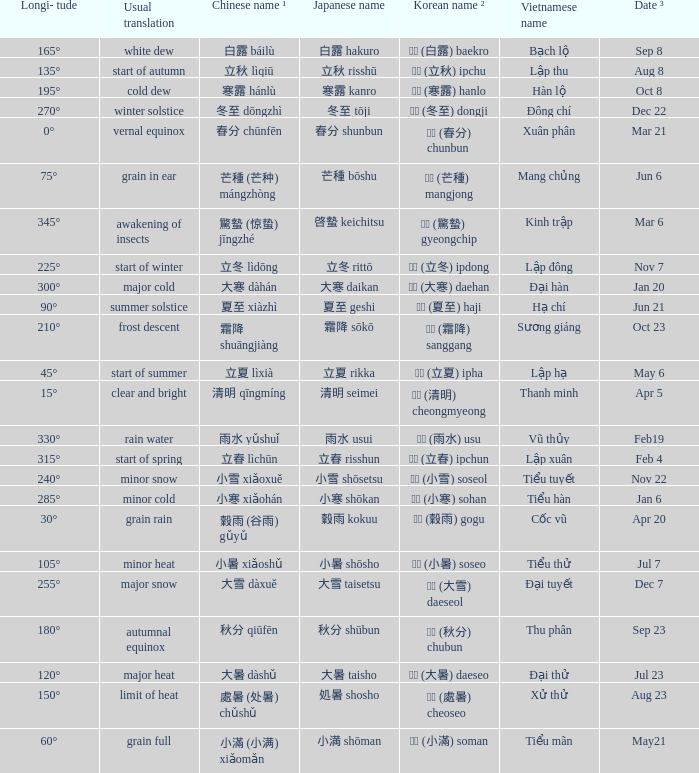Could you parse the entire table? {'header': ['Longi- tude', 'Usual translation', 'Chinese name ¹', 'Japanese name', 'Korean name ²', 'Vietnamese name', 'Date ³'], 'rows': [['165°', 'white dew', '白露 báilù', '白露 hakuro', '백로 (白露) baekro', 'Bạch lộ', 'Sep 8'], ['135°', 'start of autumn', '立秋 lìqiū', '立秋 risshū', '입추 (立秋) ipchu', 'Lập thu', 'Aug 8'], ['195°', 'cold dew', '寒露 hánlù', '寒露 kanro', '한로 (寒露) hanlo', 'Hàn lộ', 'Oct 8'], ['270°', 'winter solstice', '冬至 dōngzhì', '冬至 tōji', '동지 (冬至) dongji', 'Đông chí', 'Dec 22'], ['0°', 'vernal equinox', '春分 chūnfēn', '春分 shunbun', '춘분 (春分) chunbun', 'Xuân phân', 'Mar 21'], ['75°', 'grain in ear', '芒種 (芒种) mángzhòng', '芒種 bōshu', '망종 (芒種) mangjong', 'Mang chủng', 'Jun 6'], ['345°', 'awakening of insects', '驚蟄 (惊蛰) jīngzhé', '啓蟄 keichitsu', '경칩 (驚蟄) gyeongchip', 'Kinh trập', 'Mar 6'], ['225°', 'start of winter', '立冬 lìdōng', '立冬 rittō', '입동 (立冬) ipdong', 'Lập đông', 'Nov 7'], ['300°', 'major cold', '大寒 dàhán', '大寒 daikan', '대한 (大寒) daehan', 'Đại hàn', 'Jan 20'], ['90°', 'summer solstice', '夏至 xiàzhì', '夏至 geshi', '하지 (夏至) haji', 'Hạ chí', 'Jun 21'], ['210°', 'frost descent', '霜降 shuāngjiàng', '霜降 sōkō', '상강 (霜降) sanggang', 'Sương giáng', 'Oct 23'], ['45°', 'start of summer', '立夏 lìxià', '立夏 rikka', '입하 (立夏) ipha', 'Lập hạ', 'May 6'], ['15°', 'clear and bright', '清明 qīngmíng', '清明 seimei', '청명 (清明) cheongmyeong', 'Thanh minh', 'Apr 5'], ['330°', 'rain water', '雨水 yǔshuǐ', '雨水 usui', '우수 (雨水) usu', 'Vũ thủy', 'Feb19'], ['315°', 'start of spring', '立春 lìchūn', '立春 risshun', '입춘 (立春) ipchun', 'Lập xuân', 'Feb 4'], ['240°', 'minor snow', '小雪 xiǎoxuě', '小雪 shōsetsu', '소설 (小雪) soseol', 'Tiểu tuyết', 'Nov 22'], ['285°', 'minor cold', '小寒 xiǎohán', '小寒 shōkan', '소한 (小寒) sohan', 'Tiểu hàn', 'Jan 6'], ['30°', 'grain rain', '穀雨 (谷雨) gǔyǔ', '穀雨 kokuu', '곡우 (穀雨) gogu', 'Cốc vũ', 'Apr 20'], ['105°', 'minor heat', '小暑 xiǎoshǔ', '小暑 shōsho', '소서 (小暑) soseo', 'Tiểu thử', 'Jul 7'], ['255°', 'major snow', '大雪 dàxuě', '大雪 taisetsu', '대설 (大雪) daeseol', 'Đại tuyết', 'Dec 7'], ['180°', 'autumnal equinox', '秋分 qiūfēn', '秋分 shūbun', '추분 (秋分) chubun', 'Thu phân', 'Sep 23'], ['120°', 'major heat', '大暑 dàshǔ', '大暑 taisho', '대서 (大暑) daeseo', 'Đại thử', 'Jul 23'], ['150°', 'limit of heat', '處暑 (处暑) chǔshǔ', '処暑 shosho', '처서 (處暑) cheoseo', 'Xử thử', 'Aug 23'], ['60°', 'grain full', '小滿 (小满) xiǎomǎn', '小満 shōman', '소만 (小滿) soman', 'Tiểu mãn', 'May21']]} WHICH Vietnamese name has a Chinese name ¹ of 芒種 (芒种) mángzhòng? Mang chủng. 